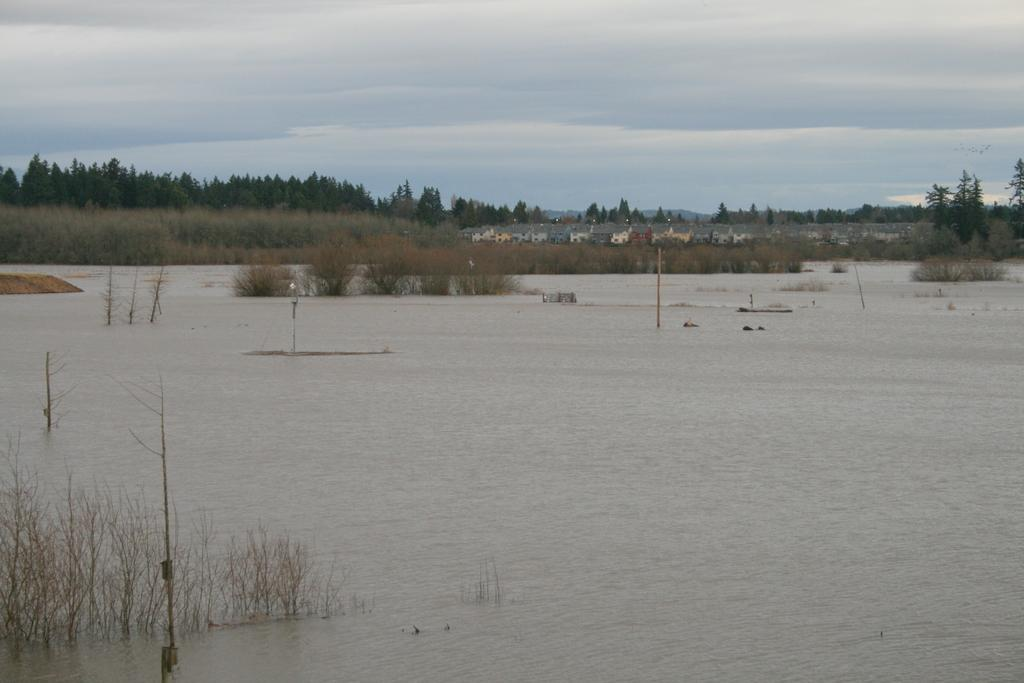What type of structures can be seen in the image? There are buildings in the image. What other natural elements are present in the image? There are trees and water visible in the image. What is visible at the top of the image? The sky is visible at the top of the image. What can be seen in the sky? There are clouds in the sky. What type of vegetation is present at the bottom of the image? There are plants at the bottom of the image. What else can be seen at the bottom of the image? There are poles in the image. How many mice are holding hands in the image? There are no mice present in the image, and therefore no mice are holding hands. What is the emotion expressed by the plants in the image? Plants do not express emotions, so it is not possible to determine the emotion they might be expressing. 